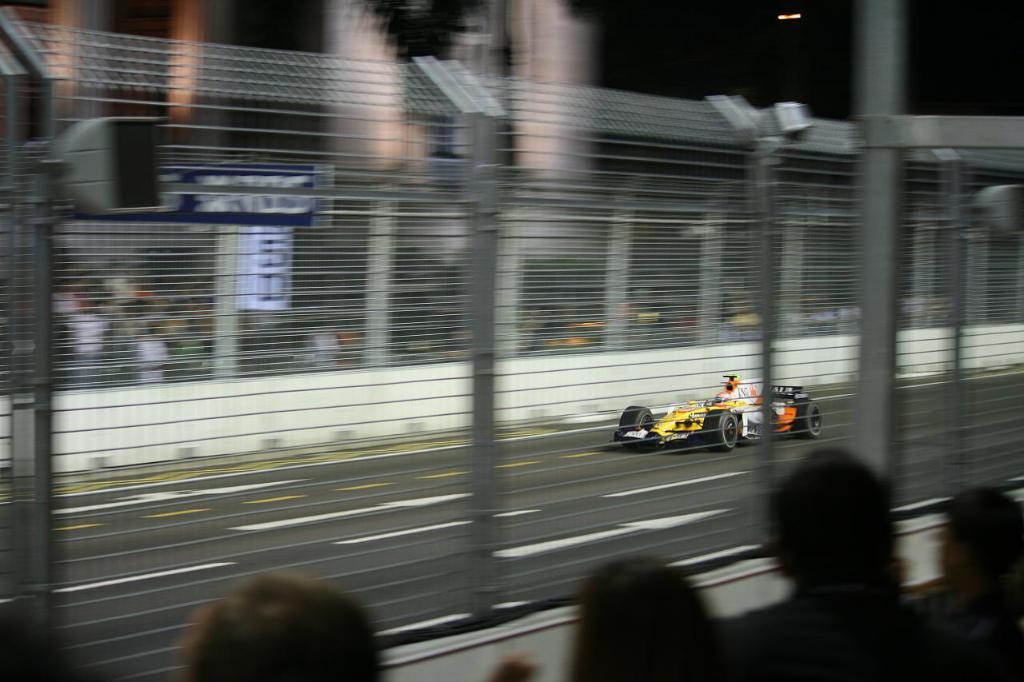Describe this image in one or two sentences. There are people and net fencing in the foreground area of the image, there are other people and a sports car in the background. 